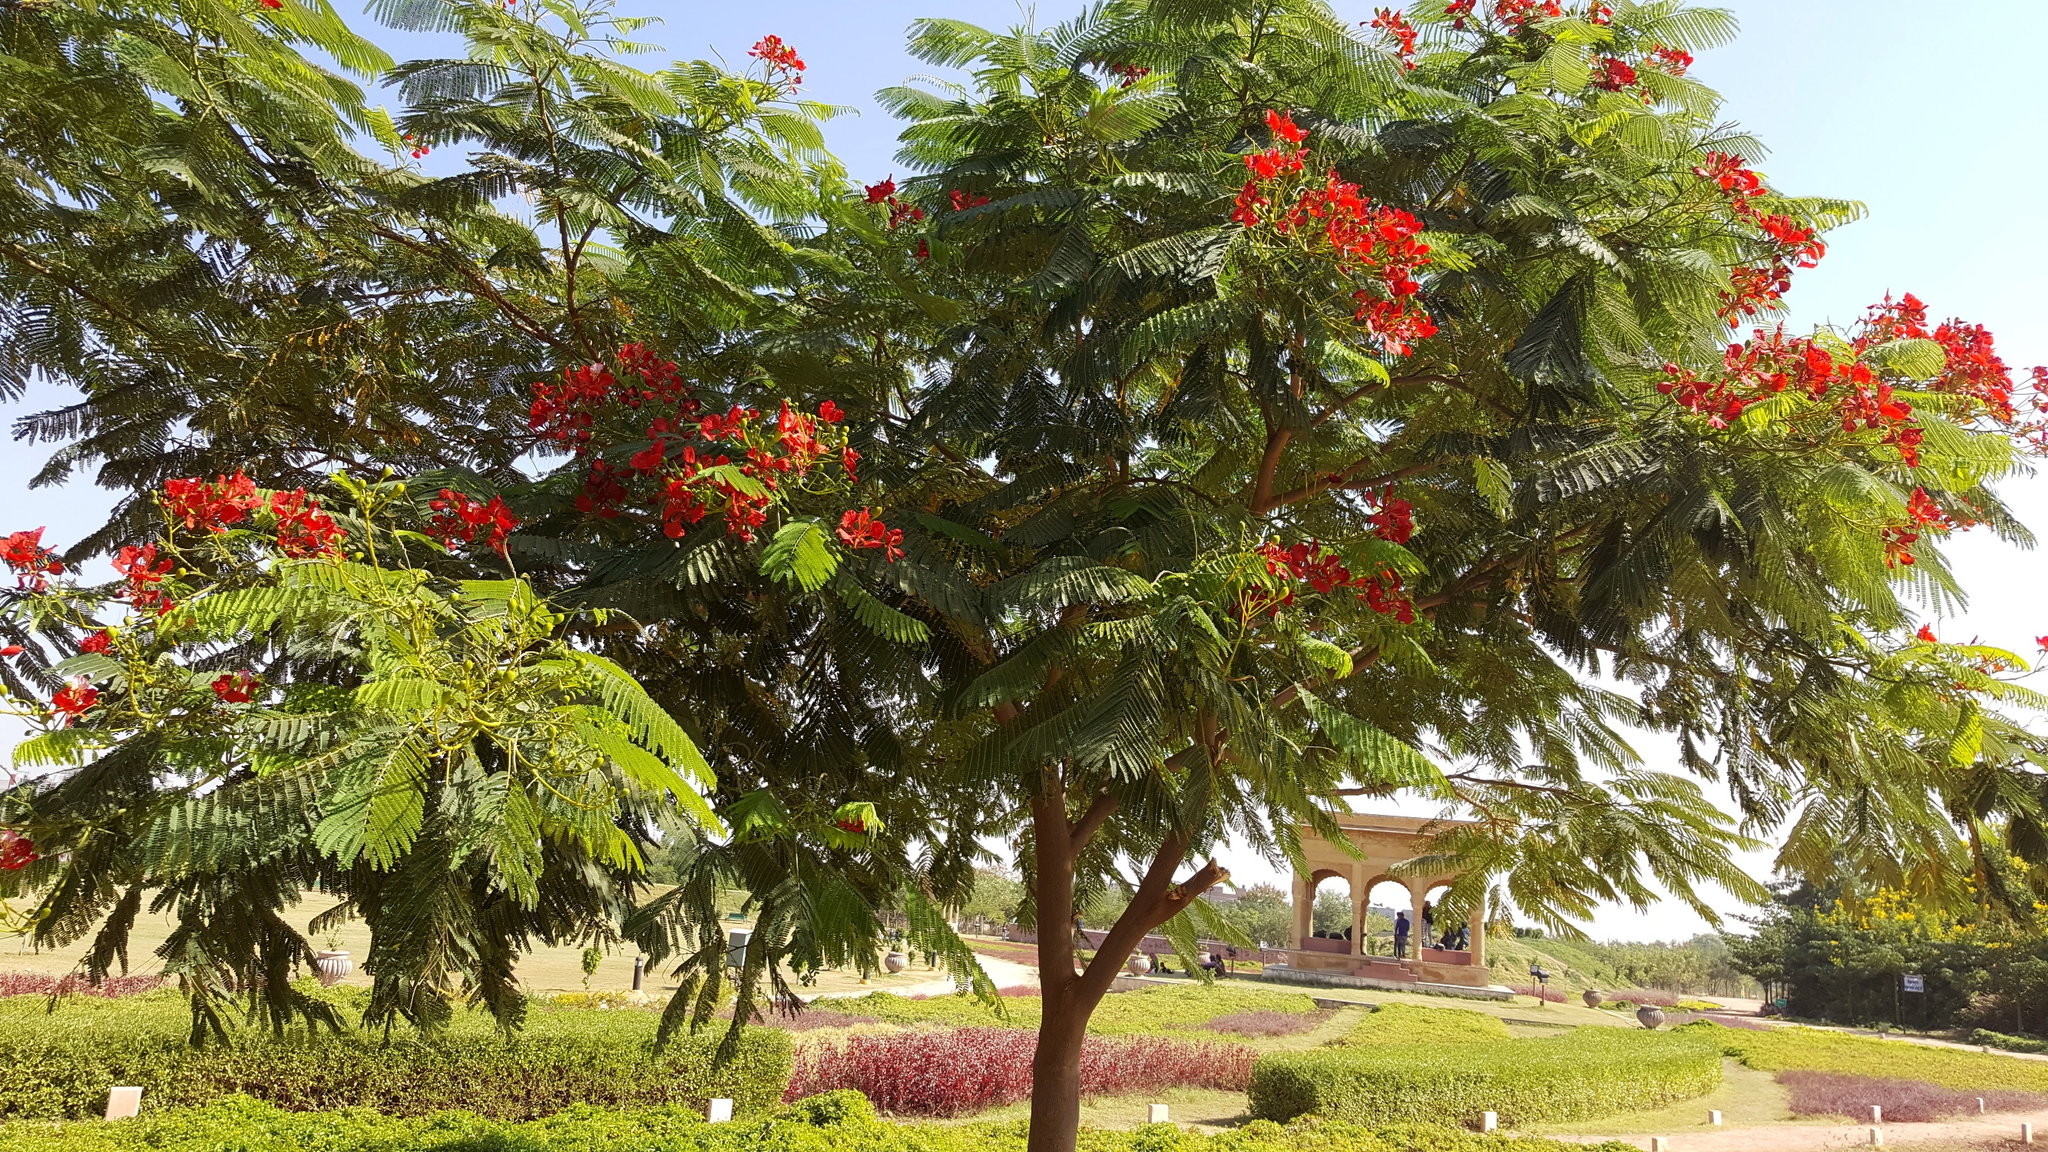Can you tell me more about the type of tree visible in this image and its characteristics? This tree is prominently featured with lush green foliage and bright red flowers, suggesting it is a Delonix regia, also known as Royal Poinciana or Flamboyant. Native to Madagascar, these trees are known for their wide-reaching canopy and quick growth, typically thriving in tropical or near-tropical climates. The vibrant red flowers are large, with four spreading scarlet or orange-red petals and one vertically elongated petal, making them quite distinctive and visually appealing. 